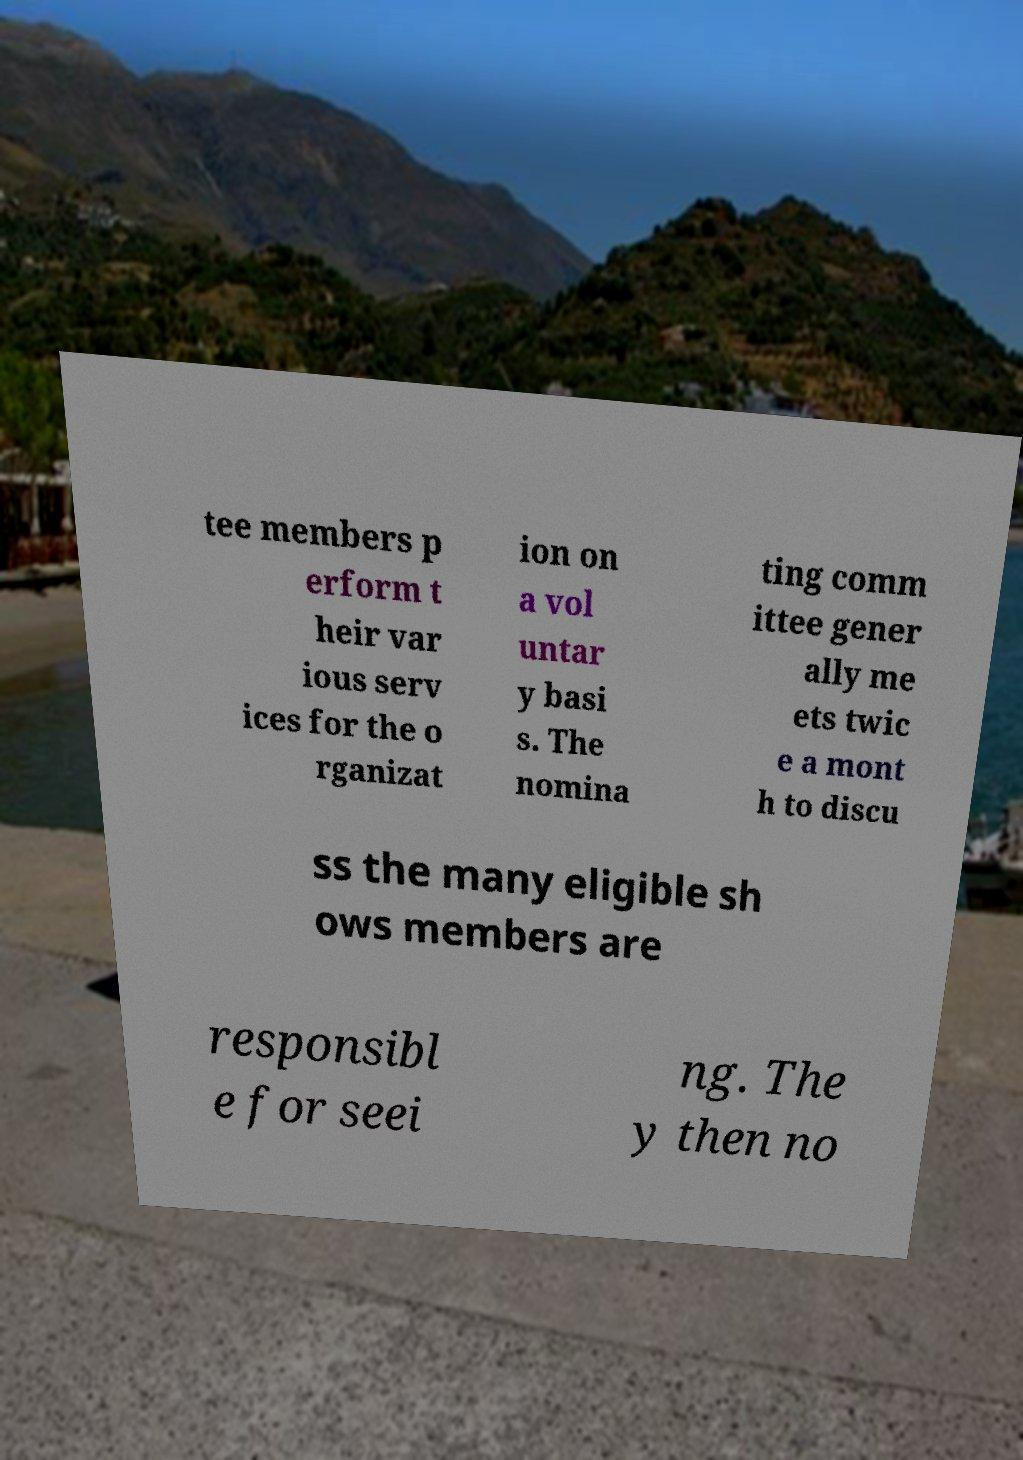Can you accurately transcribe the text from the provided image for me? tee members p erform t heir var ious serv ices for the o rganizat ion on a vol untar y basi s. The nomina ting comm ittee gener ally me ets twic e a mont h to discu ss the many eligible sh ows members are responsibl e for seei ng. The y then no 